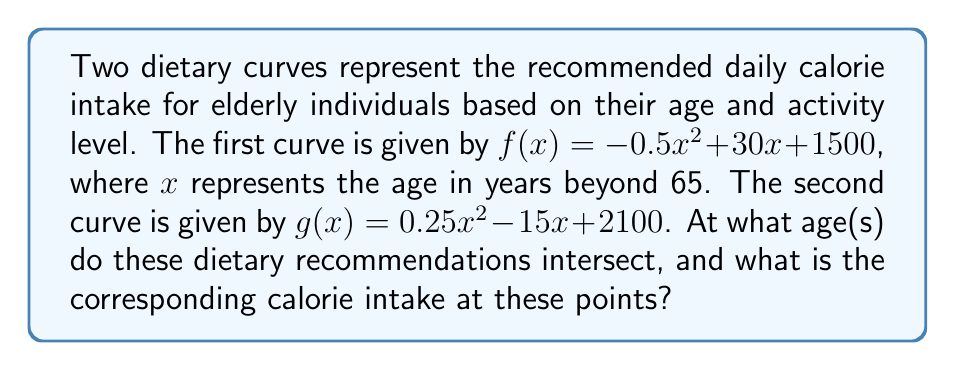What is the answer to this math problem? To find the intersection points of these two curves, we need to solve the equation $f(x) = g(x)$.

1) Set up the equation:
   $-0.5x^2 + 30x + 1500 = 0.25x^2 - 15x + 2100$

2) Rearrange the equation to standard form:
   $-0.5x^2 + 30x + 1500 - (0.25x^2 - 15x + 2100) = 0$
   $-0.75x^2 + 45x - 600 = 0$

3) Multiply all terms by -4/3 to simplify the coefficient of $x^2$:
   $x^2 - 60x + 800 = 0$

4) This is a quadratic equation. We can solve it using the quadratic formula:
   $x = \frac{-b \pm \sqrt{b^2 - 4ac}}{2a}$
   
   Where $a = 1$, $b = -60$, and $c = 800$

5) Substituting these values:
   $x = \frac{60 \pm \sqrt{(-60)^2 - 4(1)(800)}}{2(1)}$
   $= \frac{60 \pm \sqrt{3600 - 3200}}{2}$
   $= \frac{60 \pm \sqrt{400}}{2}$
   $= \frac{60 \pm 20}{2}$

6) This gives us two solutions:
   $x_1 = \frac{60 + 20}{2} = 40$ and $x_2 = \frac{60 - 20}{2} = 20$

7) Remember that $x$ represents years beyond 65, so we need to add 65 to these values to get the actual ages.

8) To find the calorie intake at these points, we can substitute either of these $x$ values into either of the original functions. Let's use $f(x)$:

   For $x_1 = 40$: $f(40) = -0.5(40)^2 + 30(40) + 1500 = 2300$ calories
   For $x_2 = 20$: $f(20) = -0.5(20)^2 + 30(20) + 1500 = 2300$ calories
Answer: Ages: 85 and 105 years; Calorie intake: 2300 calories 